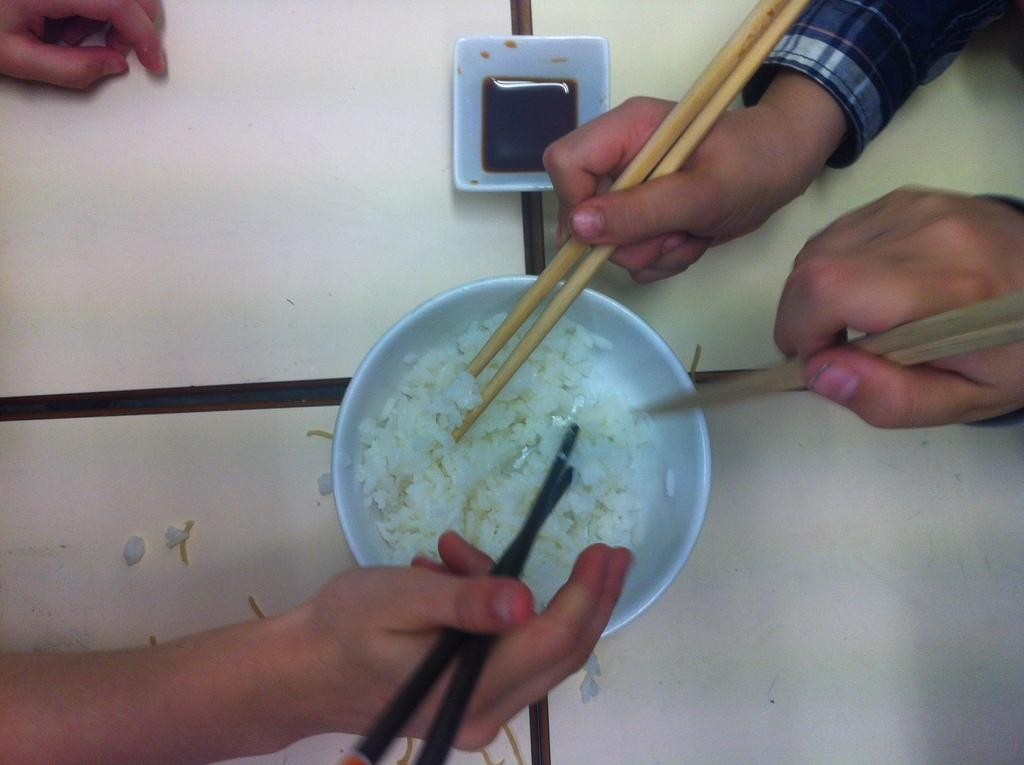What is in the bowl that is visible in the image? The bowl contains rice. Besides the bowl of rice, what other items can be seen in the image? There is a small bowl in the image that contains sour soup. What are the people in the image using to eat the rice and sour soup? The people are holding chopsticks. How many bowls are visible in the image? There are two bowls visible in the image, one containing rice and the other containing sour soup. What type of beam is holding up the ceiling in the image? There is no beam visible in the image; it is focused on the bowls and people eating. 